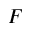<formula> <loc_0><loc_0><loc_500><loc_500>F</formula> 